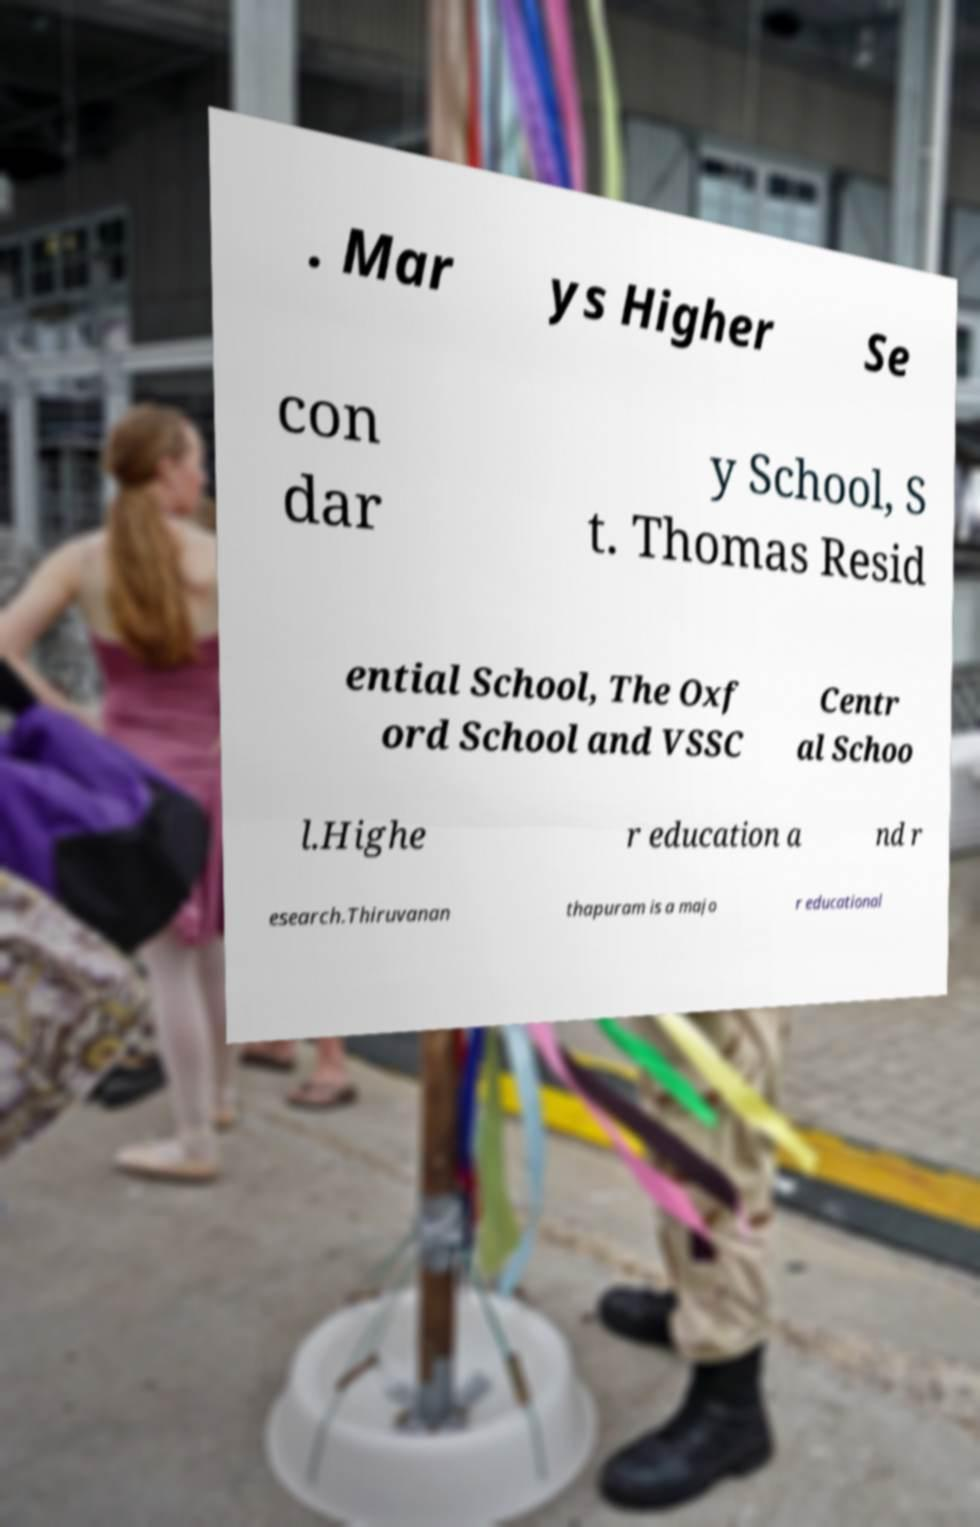Can you read and provide the text displayed in the image?This photo seems to have some interesting text. Can you extract and type it out for me? . Mar ys Higher Se con dar y School, S t. Thomas Resid ential School, The Oxf ord School and VSSC Centr al Schoo l.Highe r education a nd r esearch.Thiruvanan thapuram is a majo r educational 